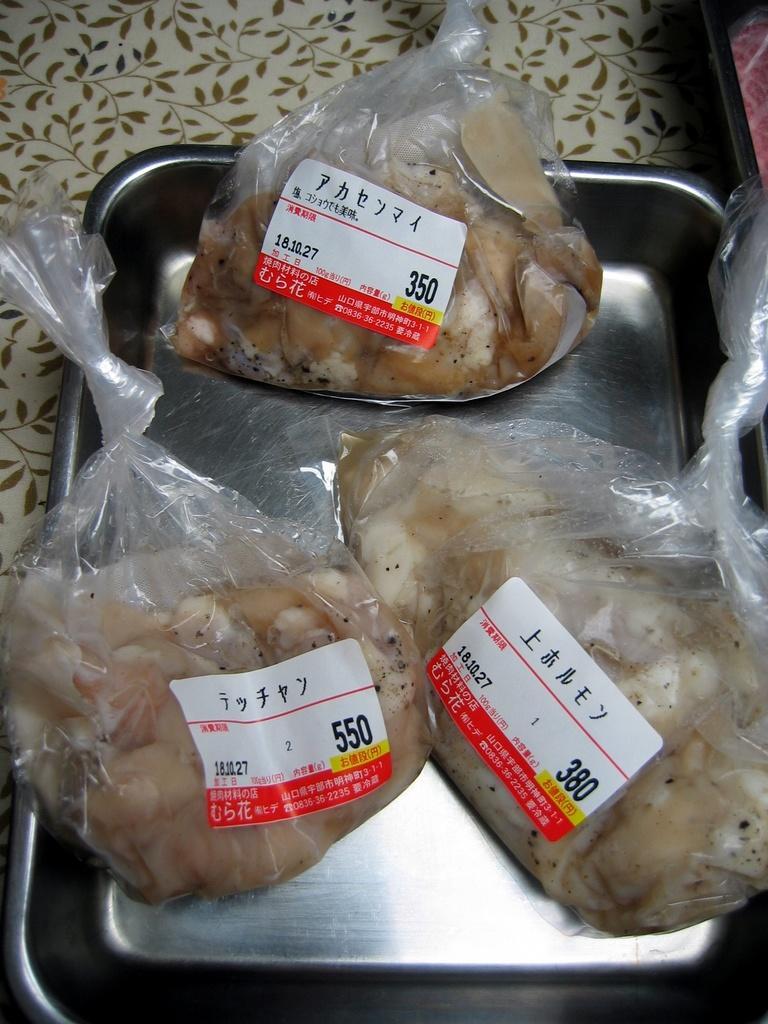In one or two sentences, can you explain what this image depicts? In this image there are three food items are kept are kept in some covers which is kept in a steel container as we can see in middle of this image and there are some fixed amount stickers are attached to these covers. 